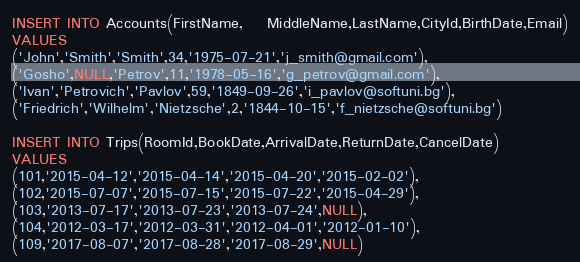<code> <loc_0><loc_0><loc_500><loc_500><_SQL_>INSERT INTO Accounts(FirstName,	MiddleName,LastName,CityId,BirthDate,Email)
VALUES
('John','Smith','Smith',34,'1975-07-21','j_smith@gmail.com'),
('Gosho',NULL,'Petrov',11,'1978-05-16','g_petrov@gmail.com'),
('Ivan','Petrovich','Pavlov',59,'1849-09-26','i_pavlov@softuni.bg'),
('Friedrich','Wilhelm','Nietzsche',2,'1844-10-15','f_nietzsche@softuni.bg')

INSERT INTO Trips(RoomId,BookDate,ArrivalDate,ReturnDate,CancelDate)
VALUES
(101,'2015-04-12','2015-04-14','2015-04-20','2015-02-02'),
(102,'2015-07-07','2015-07-15','2015-07-22','2015-04-29'),
(103,'2013-07-17','2013-07-23','2013-07-24',NULL),
(104,'2012-03-17','2012-03-31','2012-04-01','2012-01-10'),
(109,'2017-08-07','2017-08-28','2017-08-29',NULL)</code> 